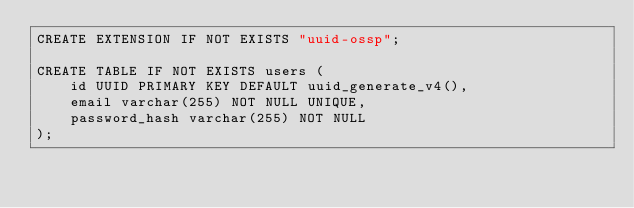<code> <loc_0><loc_0><loc_500><loc_500><_SQL_>CREATE EXTENSION IF NOT EXISTS "uuid-ossp";

CREATE TABLE IF NOT EXISTS users (
    id UUID PRIMARY KEY DEFAULT uuid_generate_v4(),
    email varchar(255) NOT NULL UNIQUE,
    password_hash varchar(255) NOT NULL
);
</code> 